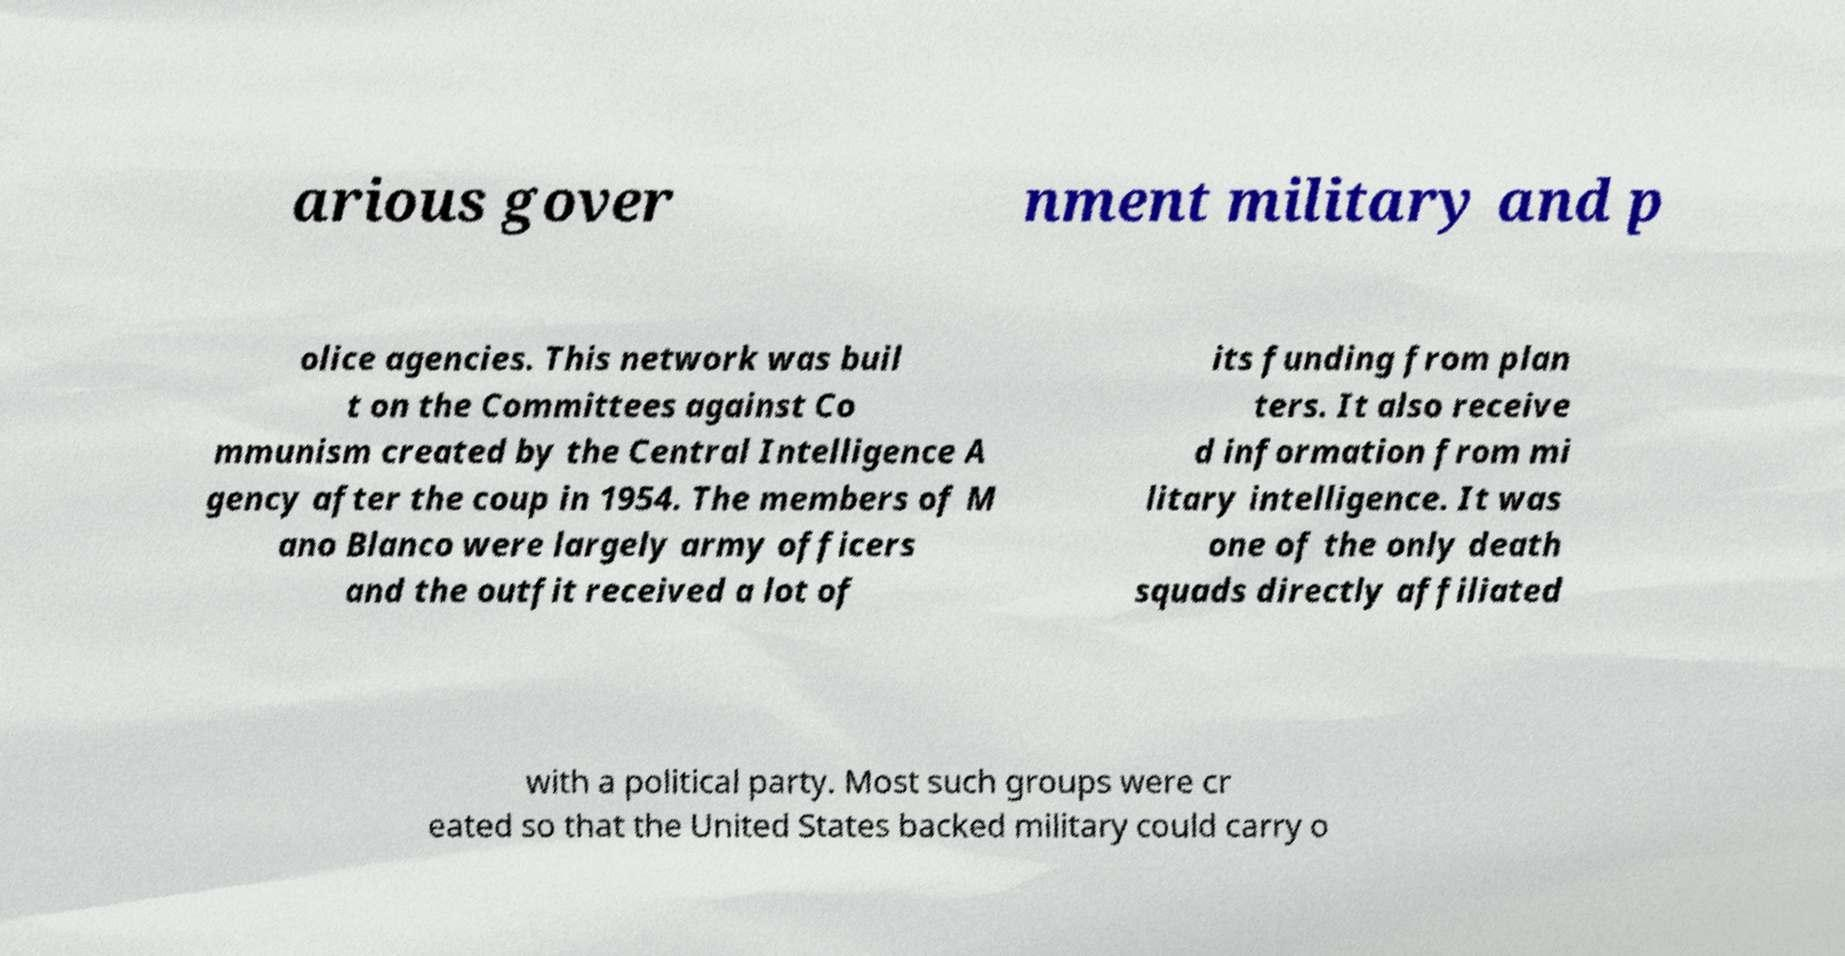I need the written content from this picture converted into text. Can you do that? arious gover nment military and p olice agencies. This network was buil t on the Committees against Co mmunism created by the Central Intelligence A gency after the coup in 1954. The members of M ano Blanco were largely army officers and the outfit received a lot of its funding from plan ters. It also receive d information from mi litary intelligence. It was one of the only death squads directly affiliated with a political party. Most such groups were cr eated so that the United States backed military could carry o 